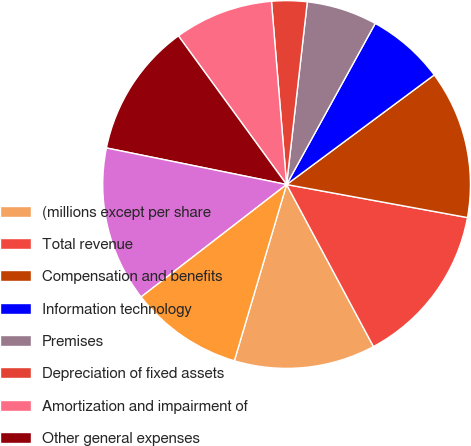Convert chart. <chart><loc_0><loc_0><loc_500><loc_500><pie_chart><fcel>(millions except per share<fcel>Total revenue<fcel>Compensation and benefits<fcel>Information technology<fcel>Premises<fcel>Depreciation of fixed assets<fcel>Amortization and impairment of<fcel>Other general expenses<fcel>Total operating expenses<fcel>Operating income<nl><fcel>12.42%<fcel>14.29%<fcel>13.04%<fcel>6.83%<fcel>6.21%<fcel>3.11%<fcel>8.7%<fcel>11.8%<fcel>13.66%<fcel>9.94%<nl></chart> 